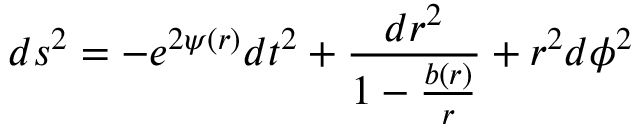<formula> <loc_0><loc_0><loc_500><loc_500>d s ^ { 2 } = - e ^ { 2 \psi ( r ) } d t ^ { 2 } + \frac { d r ^ { 2 } } { 1 - \frac { b ( r ) } { r } } + r ^ { 2 } d \phi ^ { 2 }</formula> 